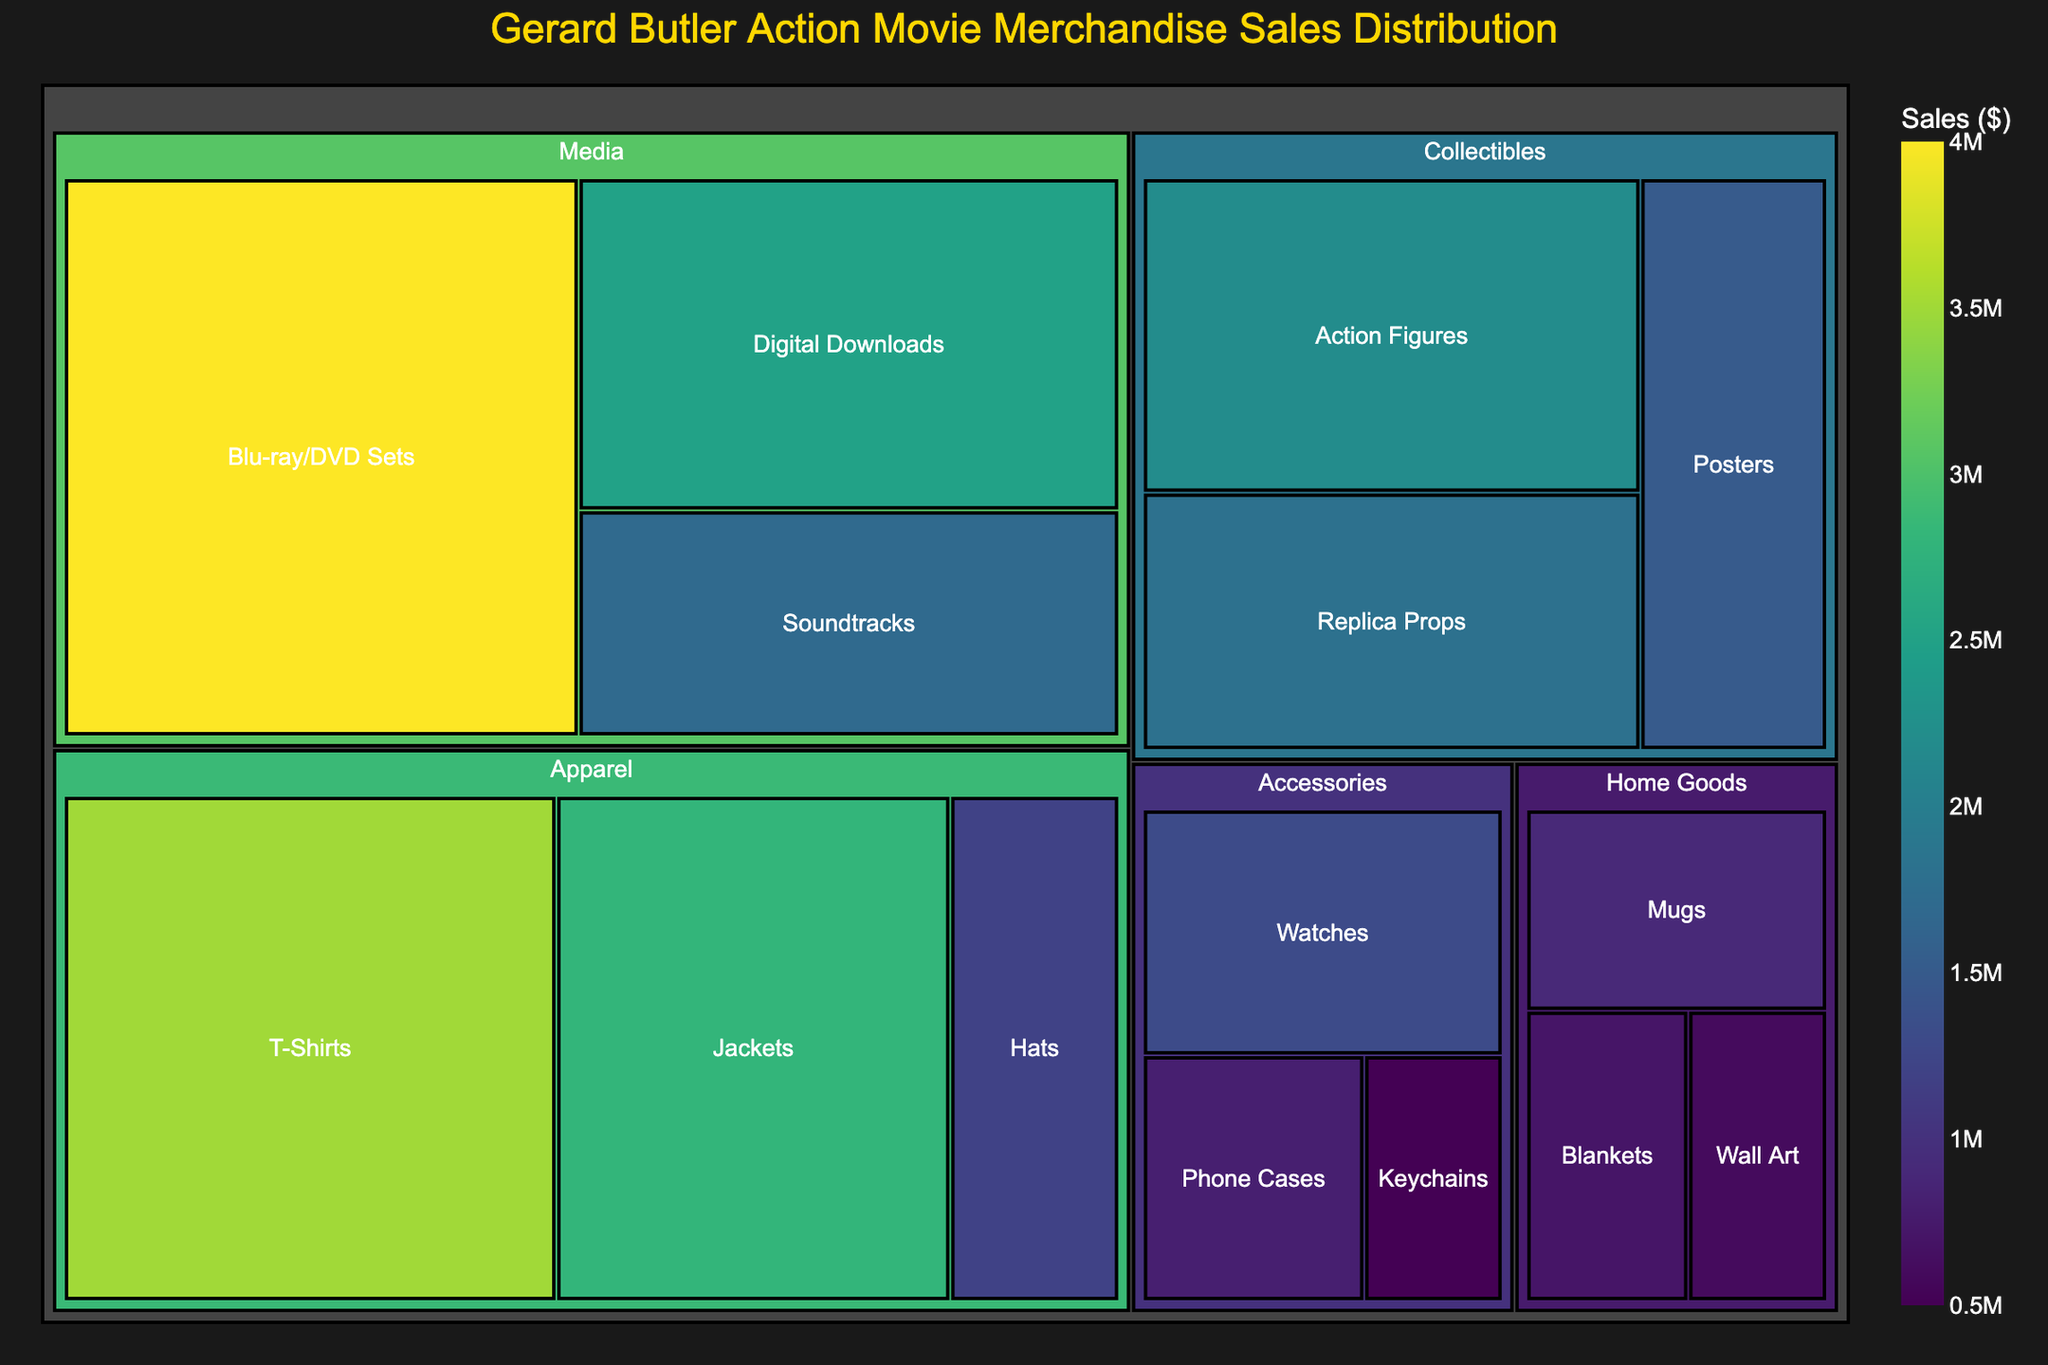Which product category has the highest sales? Look at the Treemap and identify the category with the largest area, indicating the highest sales value.
Answer: Media Which subcategory within Apparel has the highest sales? Look within the Apparel section of the Treemap and find the subcategory with the largest area.
Answer: T-Shirts How much are the total sales for the Collectibles category? Sum up the sales values for all subcategories within Collectibles: Action Figures ($2,200,000) + Replica Props ($1,800,000) + Posters ($1,500,000). Total is $2,200,000 + $1,800,000 + $1,500,000 = $5,500,000
Answer: $5,500,000 Which subcategory has higher sales, Blu-ray/DVD Sets or Digital Downloads? Compare the areas for Blu-ray/DVD Sets and Digital Downloads within the Media category.
Answer: Blu-ray/DVD Sets What is the sales difference between Hats and Posters? Look at the sales values for Hats ($1,200,000) and Posters ($1,500,000) and subtract one from the other. The difference is $1,500,000 - $1,200,000 = $300,000
Answer: $300,000 How do the sales of Phone Cases compare to Watches? Compare the sales values for Phone Cases ($800,000) and Watches ($1,300,000).
Answer: Less Which Home Goods subcategory has the smallest sales? Identify the subcategory in Home Goods with the smallest area, which corresponds to the smallest sales value.
Answer: Wall Art What are the combined sales for all Media subcategories? Sum up the sales values for all subcategories within Media: Blu-ray/DVD Sets ($4,000,000) + Soundtracks ($1,700,000) + Digital Downloads ($2,500,000). Total is $4,000,000 + $1,700,000 + $2,500,000 = $8,200,000
Answer: $8,200,000 Is the sales value for Jackets higher or lower than Keychains? Compare the sales values for Jackets ($2,800,000) and Keychains ($500,000).
Answer: Higher What subcategory within Accessories has the highest sales? Identify the subcategory within Accessories with the largest area, indicating the highest sales value.
Answer: Watches 